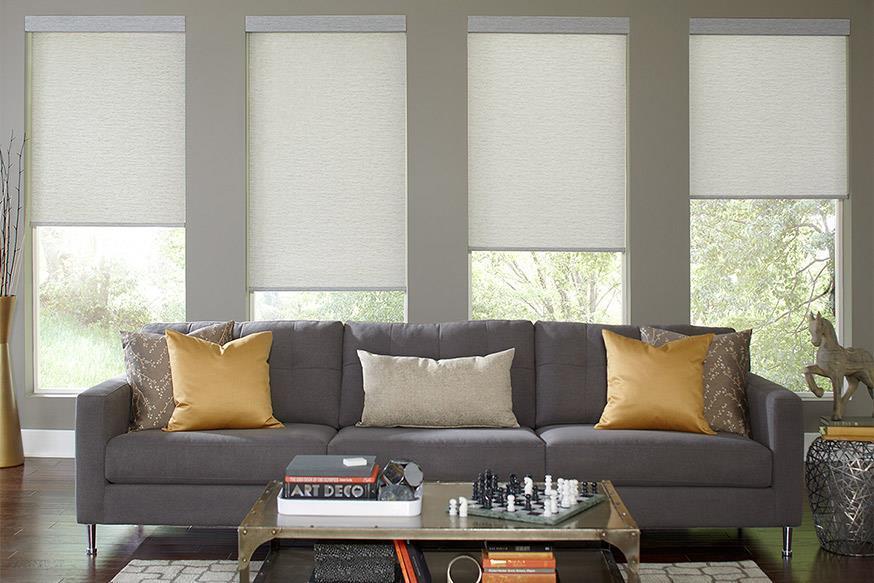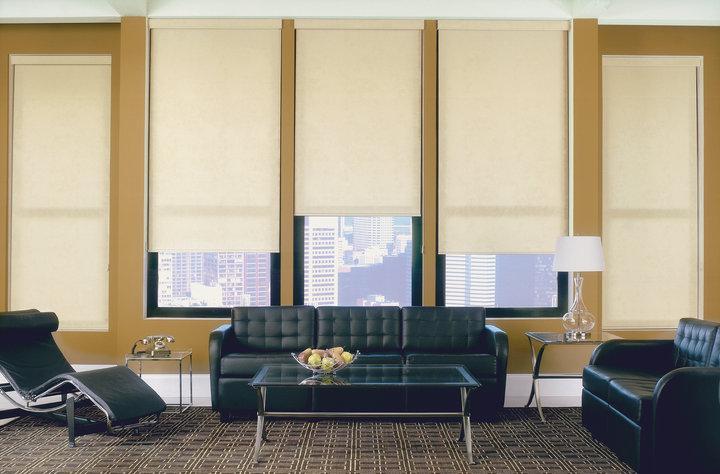The first image is the image on the left, the second image is the image on the right. Assess this claim about the two images: "All the shades are partially open.". Correct or not? Answer yes or no. No. The first image is the image on the left, the second image is the image on the right. For the images displayed, is the sentence "There are two windows in the left image." factually correct? Answer yes or no. No. 